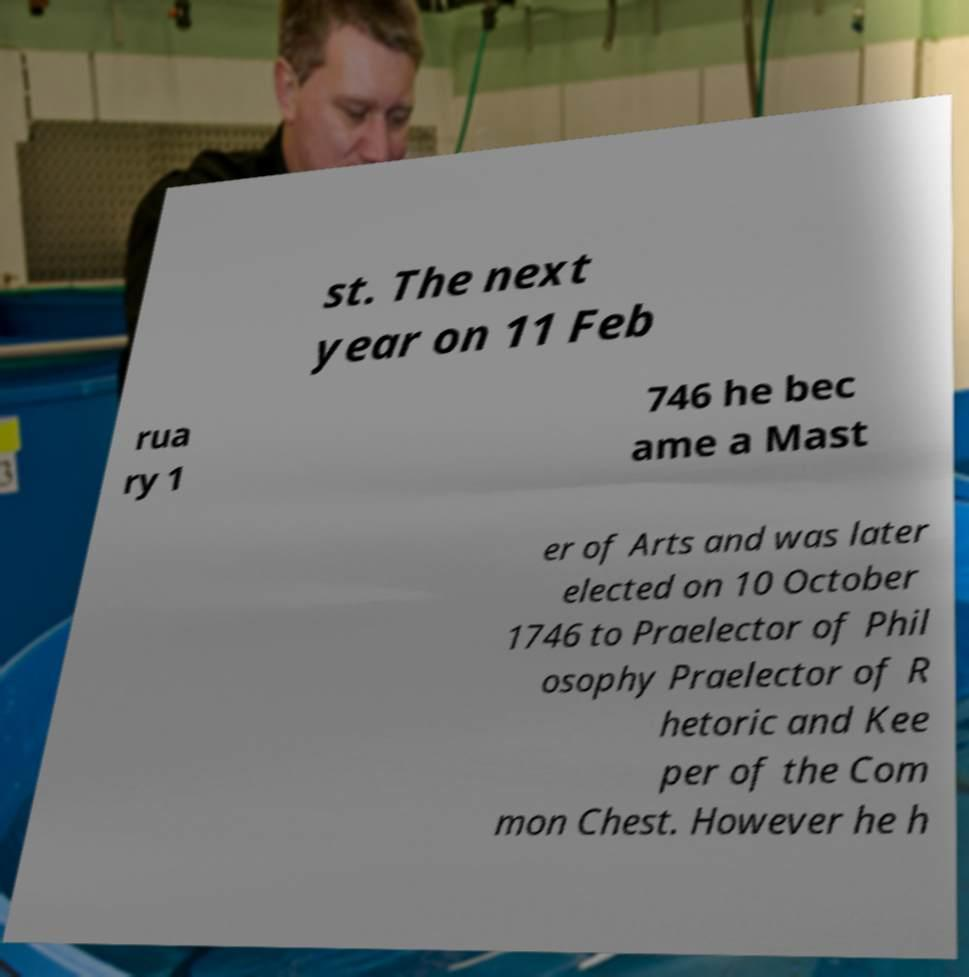Can you accurately transcribe the text from the provided image for me? st. The next year on 11 Feb rua ry 1 746 he bec ame a Mast er of Arts and was later elected on 10 October 1746 to Praelector of Phil osophy Praelector of R hetoric and Kee per of the Com mon Chest. However he h 